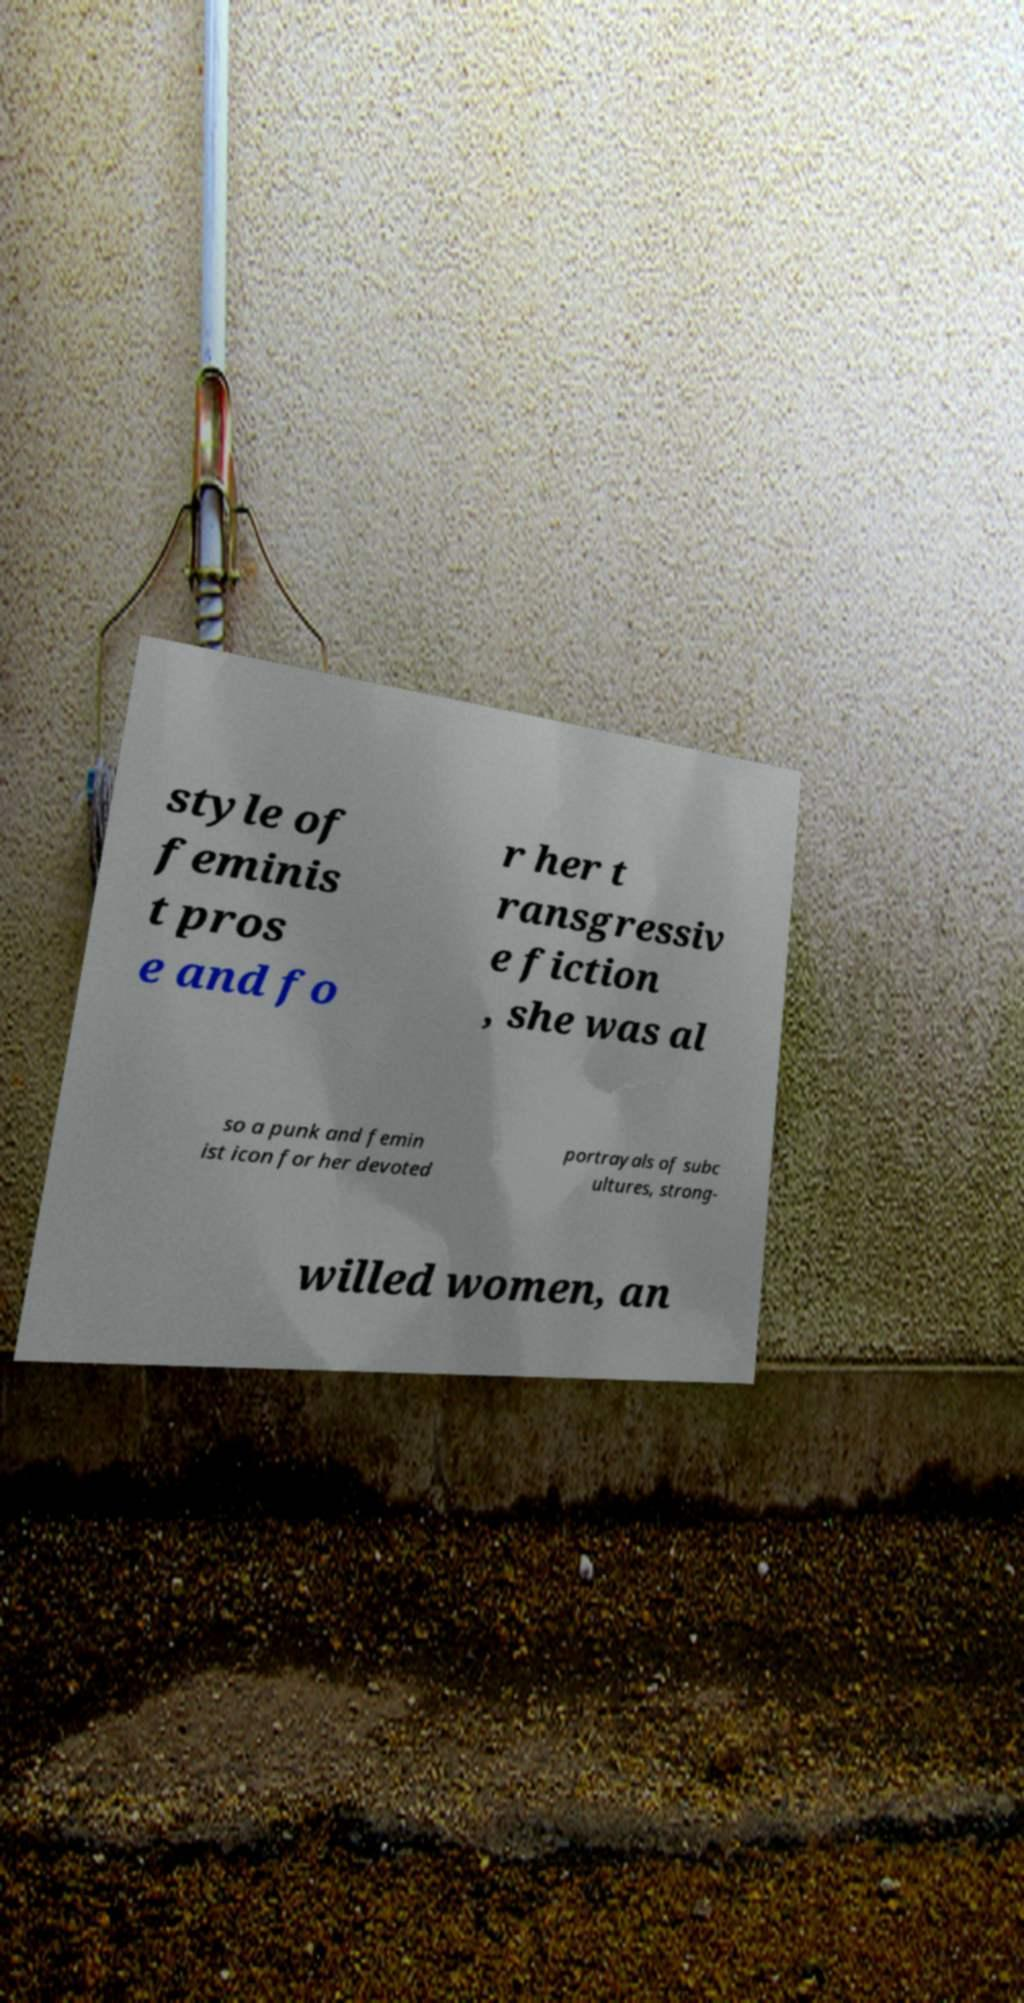Can you accurately transcribe the text from the provided image for me? style of feminis t pros e and fo r her t ransgressiv e fiction , she was al so a punk and femin ist icon for her devoted portrayals of subc ultures, strong- willed women, an 